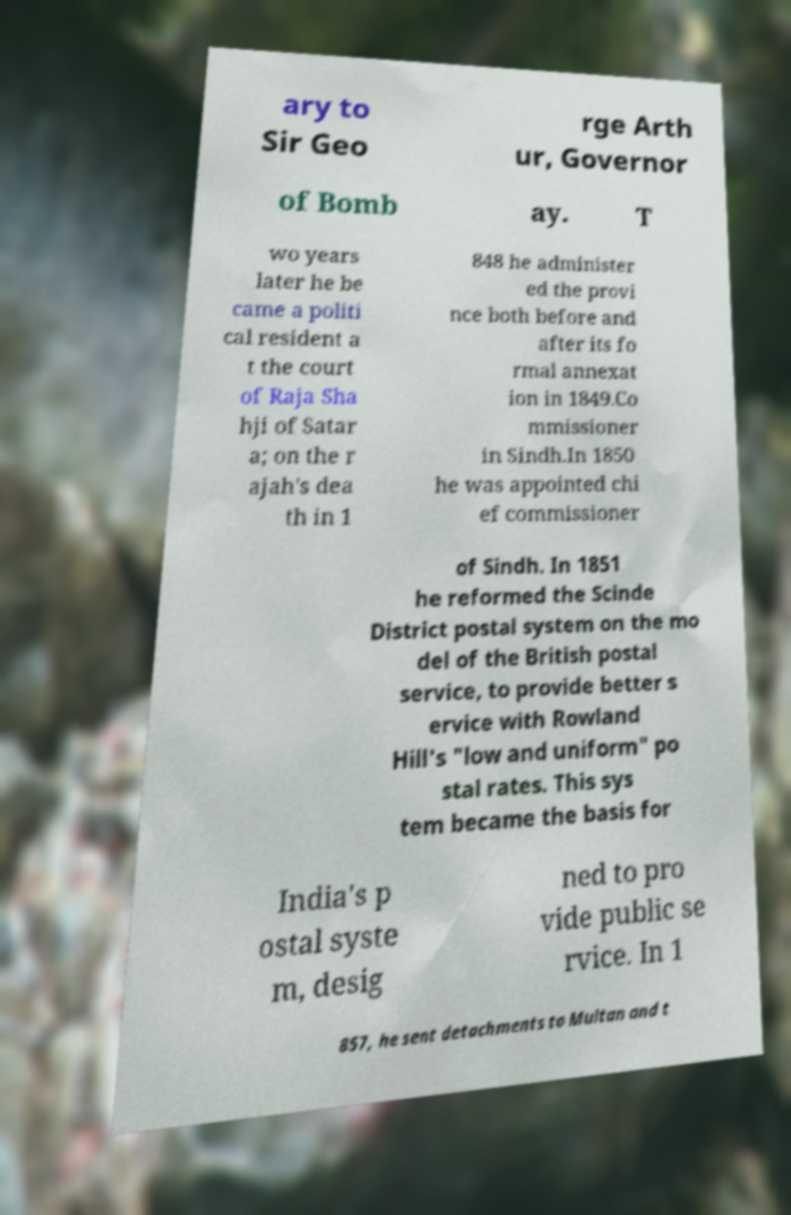Could you extract and type out the text from this image? ary to Sir Geo rge Arth ur, Governor of Bomb ay. T wo years later he be came a politi cal resident a t the court of Raja Sha hji of Satar a; on the r ajah's dea th in 1 848 he administer ed the provi nce both before and after its fo rmal annexat ion in 1849.Co mmissioner in Sindh.In 1850 he was appointed chi ef commissioner of Sindh. In 1851 he reformed the Scinde District postal system on the mo del of the British postal service, to provide better s ervice with Rowland Hill's "low and uniform" po stal rates. This sys tem became the basis for India's p ostal syste m, desig ned to pro vide public se rvice. In 1 857, he sent detachments to Multan and t 